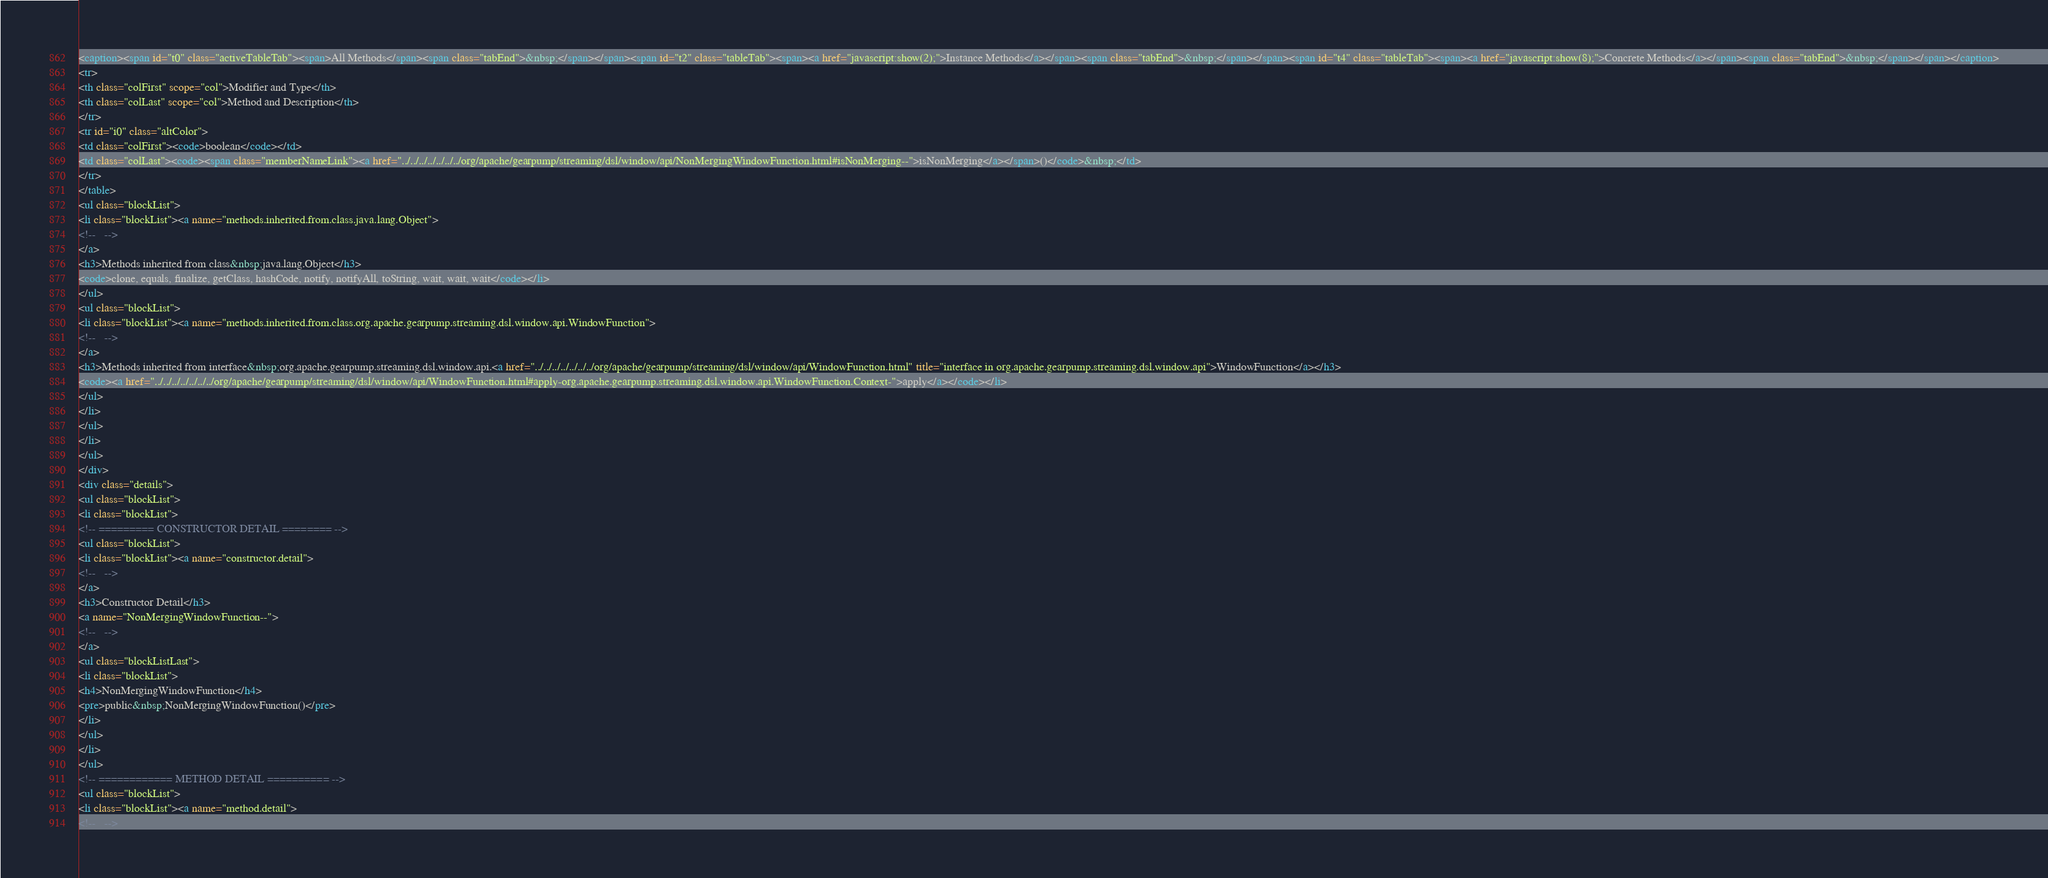<code> <loc_0><loc_0><loc_500><loc_500><_HTML_><caption><span id="t0" class="activeTableTab"><span>All Methods</span><span class="tabEnd">&nbsp;</span></span><span id="t2" class="tableTab"><span><a href="javascript:show(2);">Instance Methods</a></span><span class="tabEnd">&nbsp;</span></span><span id="t4" class="tableTab"><span><a href="javascript:show(8);">Concrete Methods</a></span><span class="tabEnd">&nbsp;</span></span></caption>
<tr>
<th class="colFirst" scope="col">Modifier and Type</th>
<th class="colLast" scope="col">Method and Description</th>
</tr>
<tr id="i0" class="altColor">
<td class="colFirst"><code>boolean</code></td>
<td class="colLast"><code><span class="memberNameLink"><a href="../../../../../../../org/apache/gearpump/streaming/dsl/window/api/NonMergingWindowFunction.html#isNonMerging--">isNonMerging</a></span>()</code>&nbsp;</td>
</tr>
</table>
<ul class="blockList">
<li class="blockList"><a name="methods.inherited.from.class.java.lang.Object">
<!--   -->
</a>
<h3>Methods inherited from class&nbsp;java.lang.Object</h3>
<code>clone, equals, finalize, getClass, hashCode, notify, notifyAll, toString, wait, wait, wait</code></li>
</ul>
<ul class="blockList">
<li class="blockList"><a name="methods.inherited.from.class.org.apache.gearpump.streaming.dsl.window.api.WindowFunction">
<!--   -->
</a>
<h3>Methods inherited from interface&nbsp;org.apache.gearpump.streaming.dsl.window.api.<a href="../../../../../../../org/apache/gearpump/streaming/dsl/window/api/WindowFunction.html" title="interface in org.apache.gearpump.streaming.dsl.window.api">WindowFunction</a></h3>
<code><a href="../../../../../../../org/apache/gearpump/streaming/dsl/window/api/WindowFunction.html#apply-org.apache.gearpump.streaming.dsl.window.api.WindowFunction.Context-">apply</a></code></li>
</ul>
</li>
</ul>
</li>
</ul>
</div>
<div class="details">
<ul class="blockList">
<li class="blockList">
<!-- ========= CONSTRUCTOR DETAIL ======== -->
<ul class="blockList">
<li class="blockList"><a name="constructor.detail">
<!--   -->
</a>
<h3>Constructor Detail</h3>
<a name="NonMergingWindowFunction--">
<!--   -->
</a>
<ul class="blockListLast">
<li class="blockList">
<h4>NonMergingWindowFunction</h4>
<pre>public&nbsp;NonMergingWindowFunction()</pre>
</li>
</ul>
</li>
</ul>
<!-- ============ METHOD DETAIL ========== -->
<ul class="blockList">
<li class="blockList"><a name="method.detail">
<!--   --></code> 